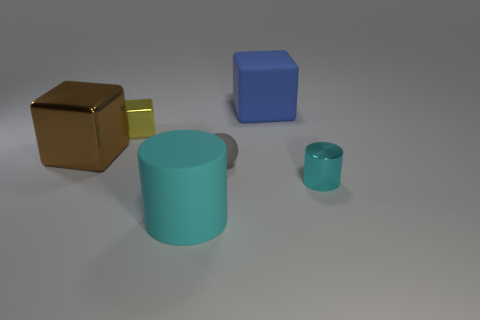Subtract all big cubes. How many cubes are left? 1 Add 3 blue metallic balls. How many objects exist? 9 Subtract all cylinders. How many objects are left? 4 Subtract 1 yellow cubes. How many objects are left? 5 Subtract all yellow blocks. Subtract all green balls. How many blocks are left? 2 Subtract all brown things. Subtract all yellow blocks. How many objects are left? 4 Add 6 big rubber blocks. How many big rubber blocks are left? 7 Add 2 shiny cylinders. How many shiny cylinders exist? 3 